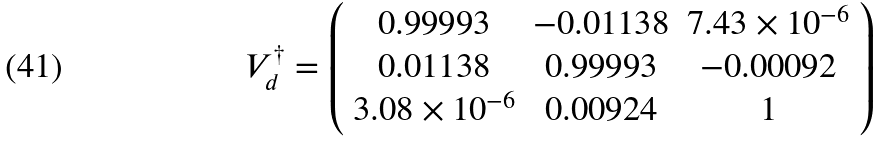<formula> <loc_0><loc_0><loc_500><loc_500>V _ { d } ^ { \dagger } = \left ( \begin{array} { c c c } 0 . 9 9 9 9 3 & - 0 . 0 1 1 3 8 & 7 . 4 3 \times 1 0 ^ { - 6 } \\ 0 . 0 1 1 3 8 & 0 . 9 9 9 9 3 & - 0 . 0 0 0 9 2 \\ 3 . 0 8 \times 1 0 ^ { - 6 } & 0 . 0 0 9 2 4 & 1 \end{array} \right )</formula> 